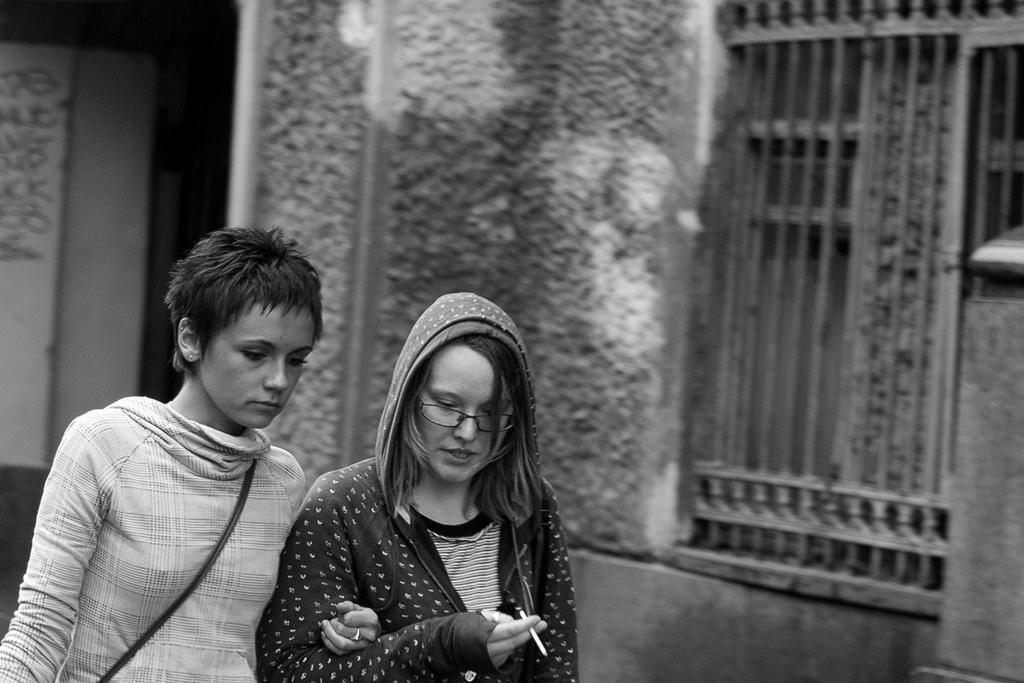How would you summarize this image in a sentence or two? In this image there are two persons standing, and in the background there is a building. 